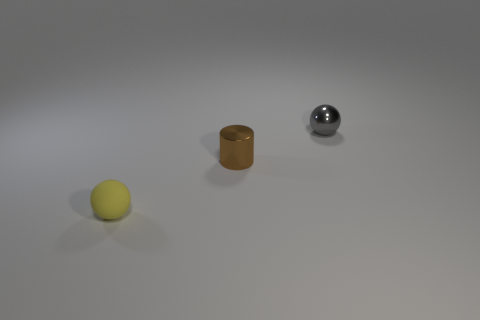Add 3 tiny balls. How many objects exist? 6 Subtract all spheres. How many objects are left? 1 Subtract 1 gray spheres. How many objects are left? 2 Subtract all big green matte things. Subtract all small yellow things. How many objects are left? 2 Add 2 metal spheres. How many metal spheres are left? 3 Add 2 tiny yellow rubber balls. How many tiny yellow rubber balls exist? 3 